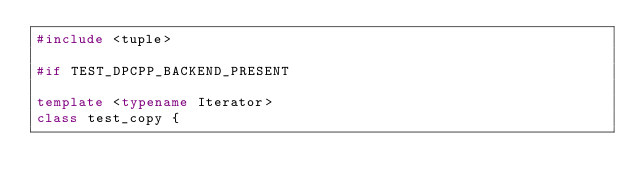<code> <loc_0><loc_0><loc_500><loc_500><_C++_>#include <tuple>

#if TEST_DPCPP_BACKEND_PRESENT

template <typename Iterator>
class test_copy {</code> 